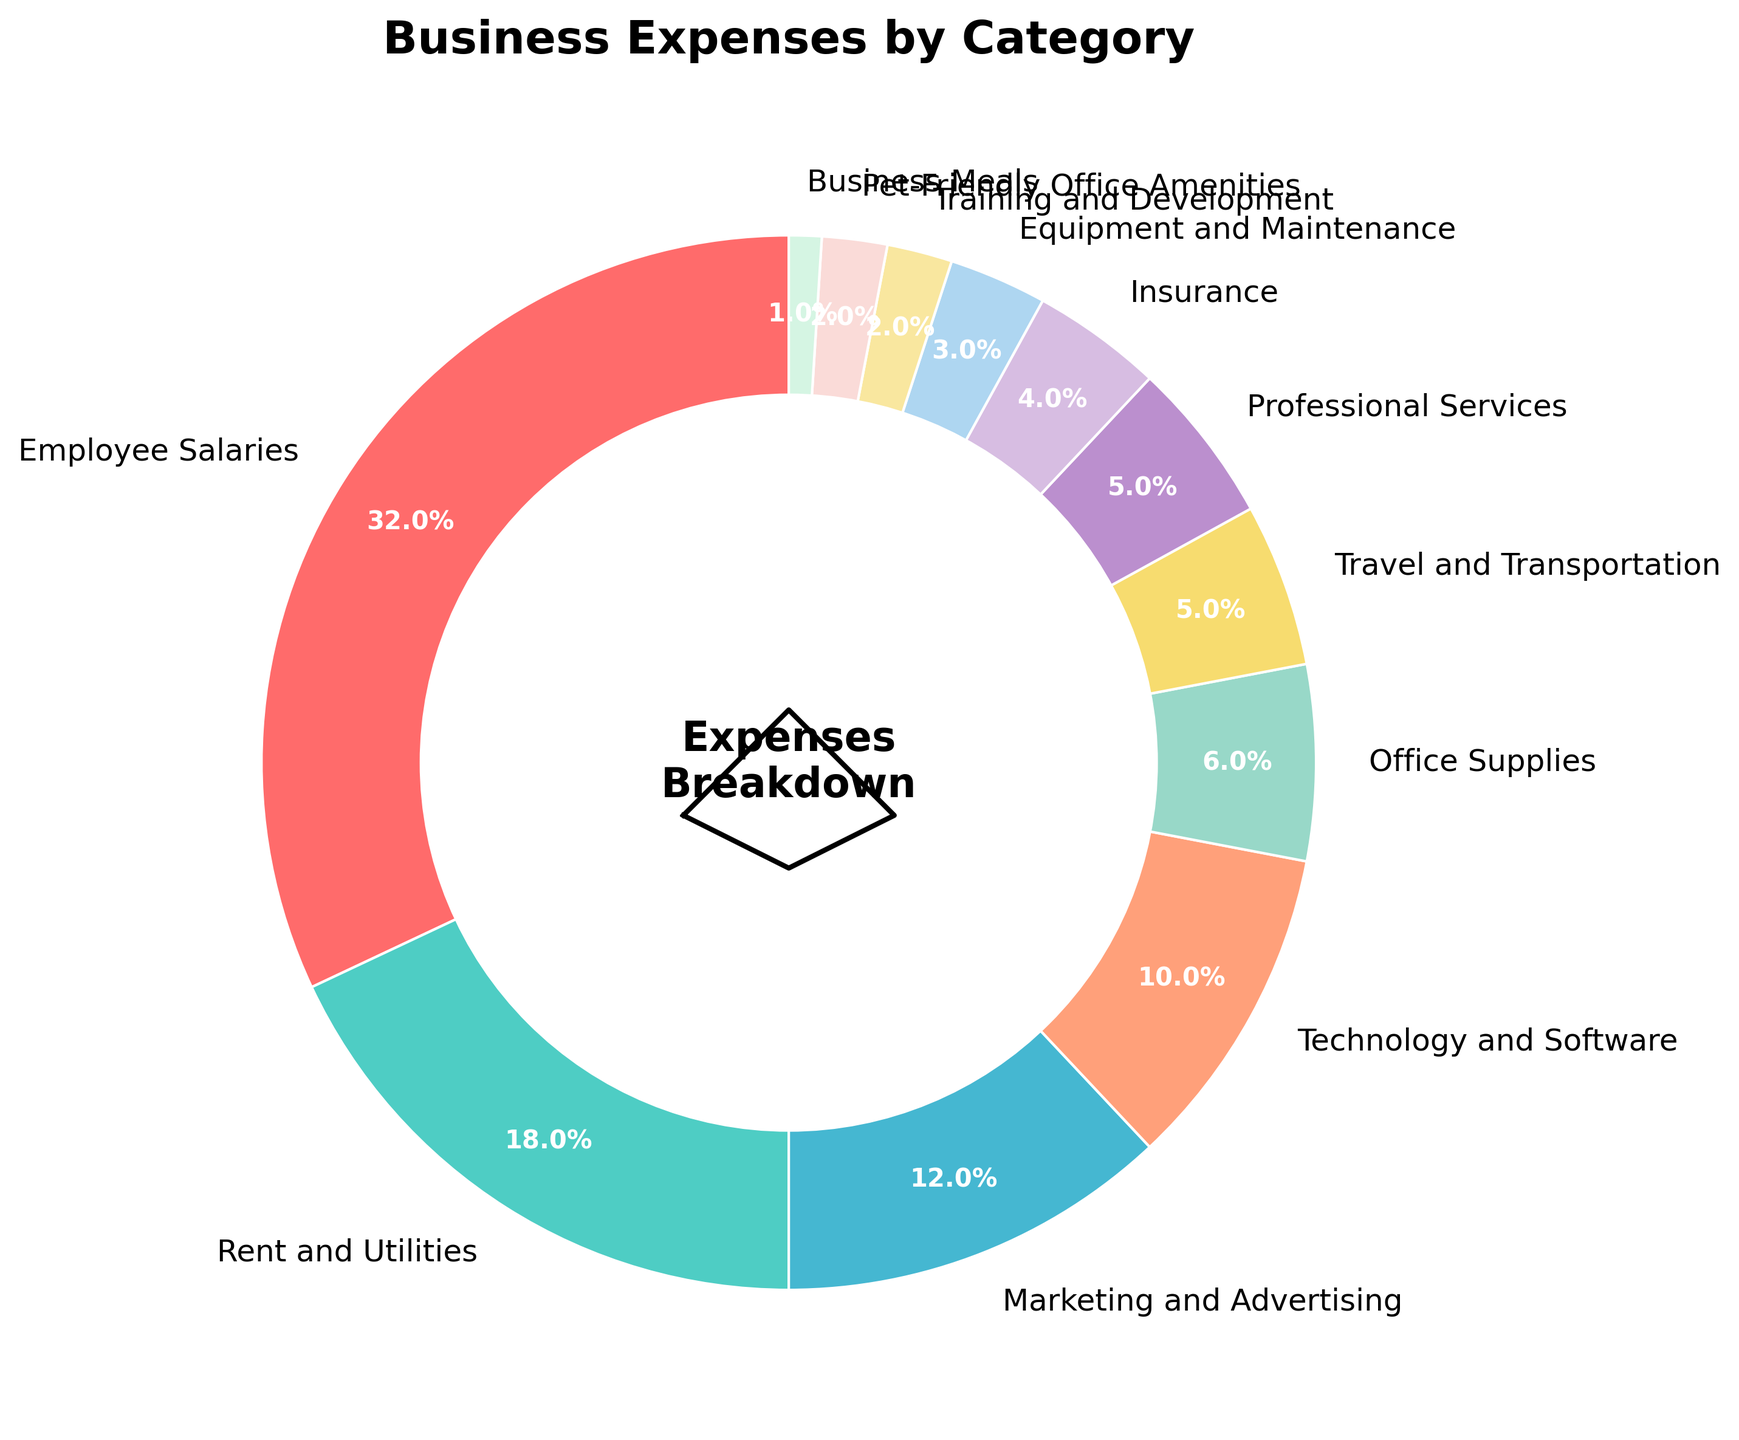What's the largest expense category? To determine the largest expense category, look at the segment with the largest percentage on the pie chart. The "Employee Salaries" category takes up 32% of the chart.
Answer: Employee Salaries Which category has the smallest percentage of expenses? Identify the category with the smallest segment on the pie chart. The "Business Meals" category, with 1%, is the smallest.
Answer: Business Meals What is the combined percentage of Employee Salaries and Rent and Utilities? Add the percentages of Employee Salaries (32%) and Rent and Utilities (18%). 32% + 18% = 50%.
Answer: 50% How much more is spent on Marketing and Advertising compared to Office Supplies? Subtract the percentage of Office Supplies (6%) from Marketing and Advertising (12%). 12% - 6% = 6%.
Answer: 6% Are the combined expenses for Travel and Transportation, Professional Services, and Insurance less than what is spent on Employee Salaries? Add the percentages of Travel and Transportation (5%), Professional Services (5%), and Insurance (4%). The sum is 5% + 5% + 4% = 14%. Since 14% is less than 32%, the answer is yes.
Answer: Yes Which category has more expenses: Technology and Software or Equipment and Maintenance? Compare the percentages of Technology and Software (10%) and Equipment and Maintenance (3%). Technology and Software has more, as 10% > 3%.
Answer: Technology and Software What is the total percentage of expenses spent on categories related to office infrastructure (Rent and Utilities, Office Supplies, Equipment and Maintenance)? Add the percentages of Rent and Utilities (18%), Office Supplies (6%), and Equipment and Maintenance (3%). 18% + 6% + 3% = 27%.
Answer: 27% Are Pet-Friendly Office Amenities and Training and Development expenses together more than Insurance? Add Pet-Friendly Office Amenities (2%) and Training and Development (2%), totaling 4%. Since Insurance is 4%, the answer is no, it is the same.
Answer: No What percentage of expenses does the "Other" category represent if we combine Travel and Transportation, Professional Services, Insurance, Equipment and Maintenance, Training and Development, Pet-Friendly Office Amenities, and Business Meals? Add the percentages of all these "other" categories: 5% (Travel and Transportation) + 5% (Professional Services) + 4% (Insurance) + 3% (Equipment and Maintenance) + 2% (Training and Development) + 2% (Pet-Friendly Office Amenities) + 1% (Business Meals) = 22%.
Answer: 22% How much more is spent on Employee Salaries than Marketing and Advertising? Subtract the percentage of Marketing and Advertising (12%) from Employee Salaries (32%). 32% - 12% = 20%.
Answer: 20% 